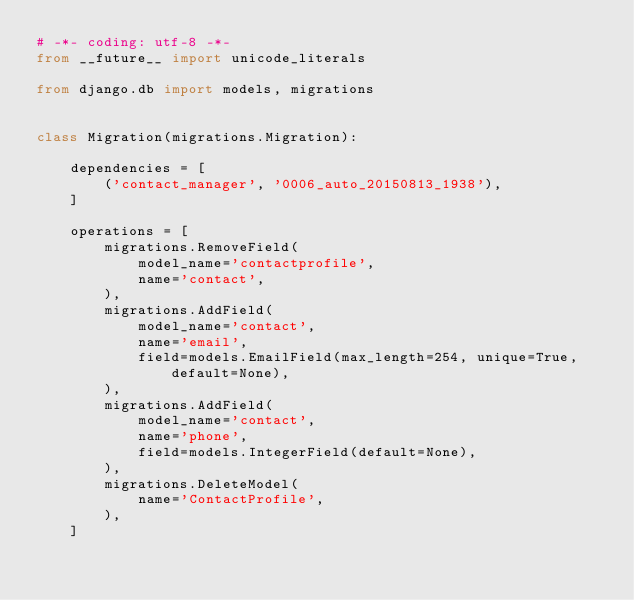Convert code to text. <code><loc_0><loc_0><loc_500><loc_500><_Python_># -*- coding: utf-8 -*-
from __future__ import unicode_literals

from django.db import models, migrations


class Migration(migrations.Migration):

    dependencies = [
        ('contact_manager', '0006_auto_20150813_1938'),
    ]

    operations = [
        migrations.RemoveField(
            model_name='contactprofile',
            name='contact',
        ),
        migrations.AddField(
            model_name='contact',
            name='email',
            field=models.EmailField(max_length=254, unique=True, default=None),
        ),
        migrations.AddField(
            model_name='contact',
            name='phone',
            field=models.IntegerField(default=None),
        ),
        migrations.DeleteModel(
            name='ContactProfile',
        ),
    ]
</code> 